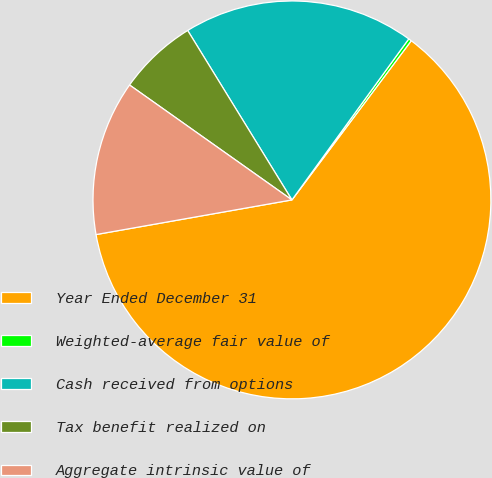<chart> <loc_0><loc_0><loc_500><loc_500><pie_chart><fcel>Year Ended December 31<fcel>Weighted-average fair value of<fcel>Cash received from options<fcel>Tax benefit realized on<fcel>Aggregate intrinsic value of<nl><fcel>61.98%<fcel>0.25%<fcel>18.77%<fcel>6.42%<fcel>12.59%<nl></chart> 